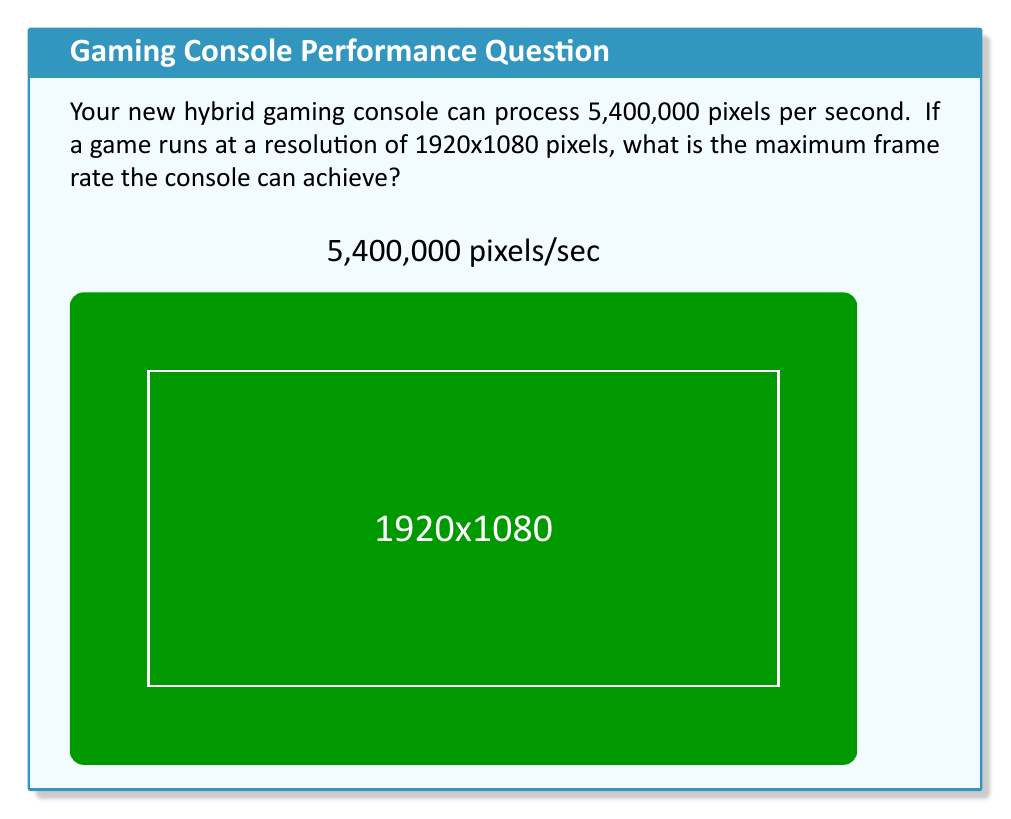Could you help me with this problem? Let's approach this step-by-step:

1) First, we need to calculate the total number of pixels in one frame:
   $$ \text{Pixels per frame} = 1920 \times 1080 = 2,073,600 \text{ pixels} $$

2) We know the console can process 5,400,000 pixels per second. To find how many frames it can process per second, we divide the total pixels per second by the pixels per frame:

   $$ \text{Frame rate} = \frac{\text{Pixels per second}}{\text{Pixels per frame}} $$

3) Plugging in our values:
   $$ \text{Frame rate} = \frac{5,400,000}{2,073,600} $$

4) Performing the division:
   $$ \text{Frame rate} = 2.60416... \approx 2.6 \text{ frames per second} $$

5) Since we're asked for the maximum frame rate, we round down to the nearest whole number, as partial frames aren't displayed.

Therefore, the maximum frame rate the console can achieve is 2 frames per second.
Answer: 2 fps 